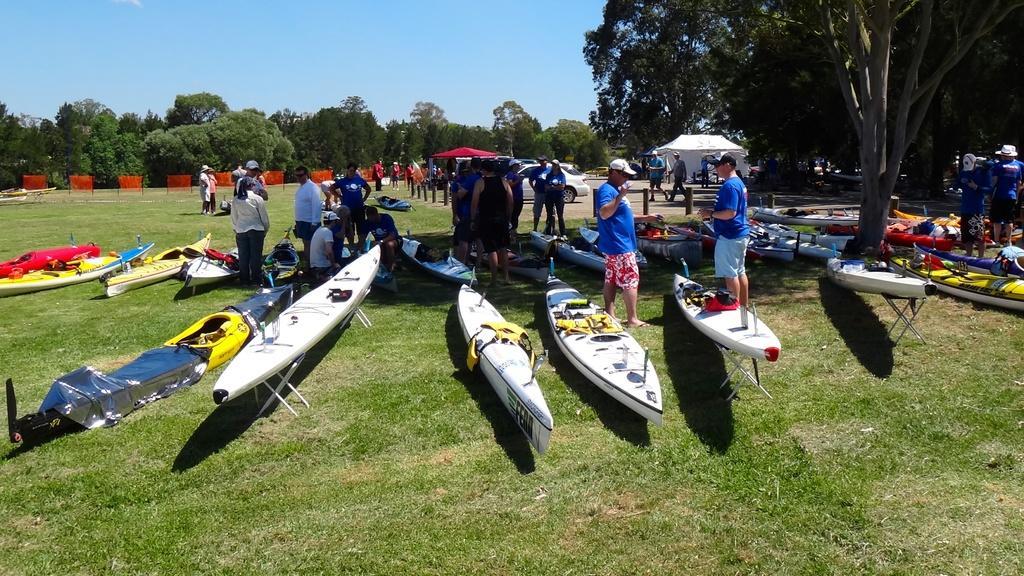In one or two sentences, can you explain what this image depicts? In the background we can see the sky and trees. In this picture we can see objects, grass, tents, vehicles, sea kayaks and people. 